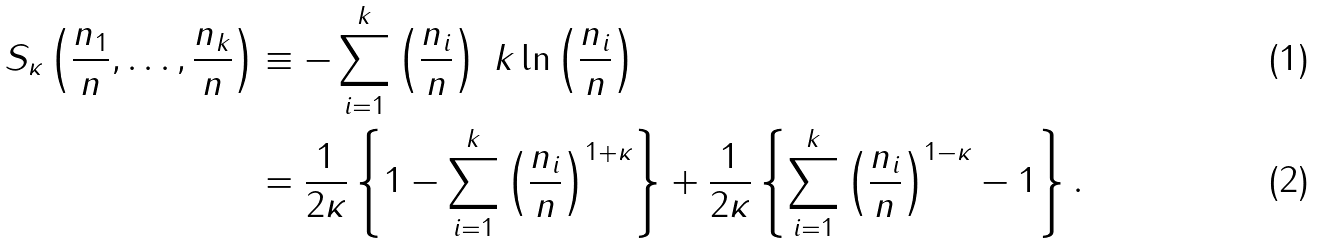<formula> <loc_0><loc_0><loc_500><loc_500>S _ { \kappa } \left ( \frac { n _ { 1 } } { n } , \dots , \frac { n _ { k } } { n } \right ) & \equiv - \sum _ { i = 1 } ^ { k } \left ( \frac { n _ { i } } { n } \right ) \ k \ln \left ( \frac { n _ { i } } { n } \right ) \\ & = \frac { 1 } { 2 \kappa } \left \{ 1 - \sum _ { i = 1 } ^ { k } \left ( \frac { n _ { i } } { n } \right ) ^ { 1 + \kappa } \right \} + \frac { 1 } { 2 \kappa } \left \{ \sum _ { i = 1 } ^ { k } \left ( \frac { n _ { i } } { n } \right ) ^ { 1 - \kappa } - 1 \right \} .</formula> 